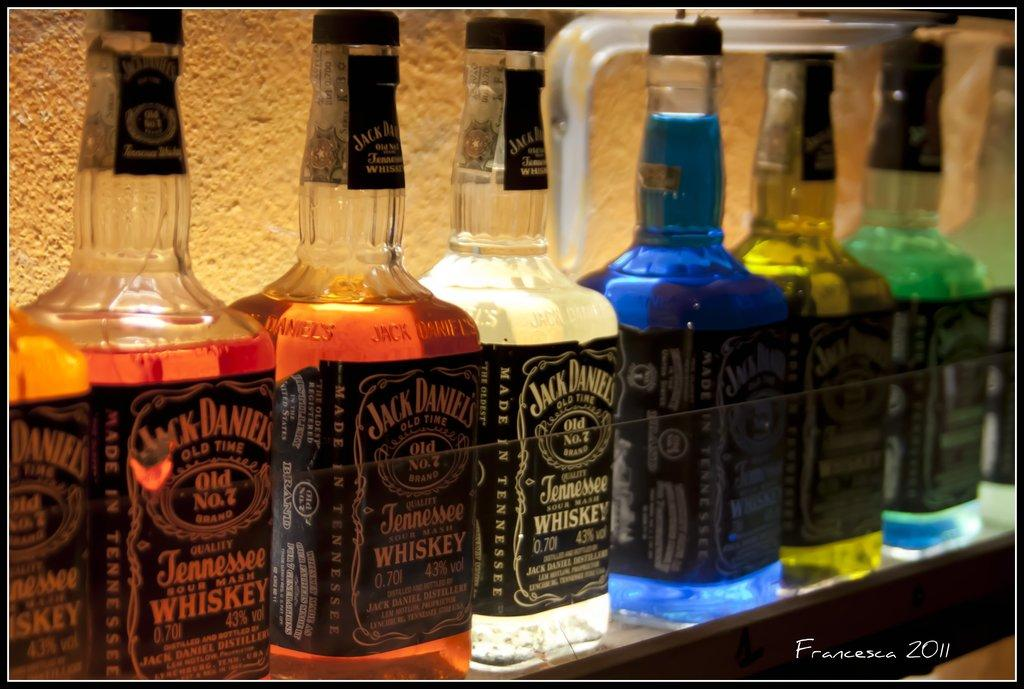<image>
Give a short and clear explanation of the subsequent image. Bottles of hard liquor such as whiskey underneath lighting 